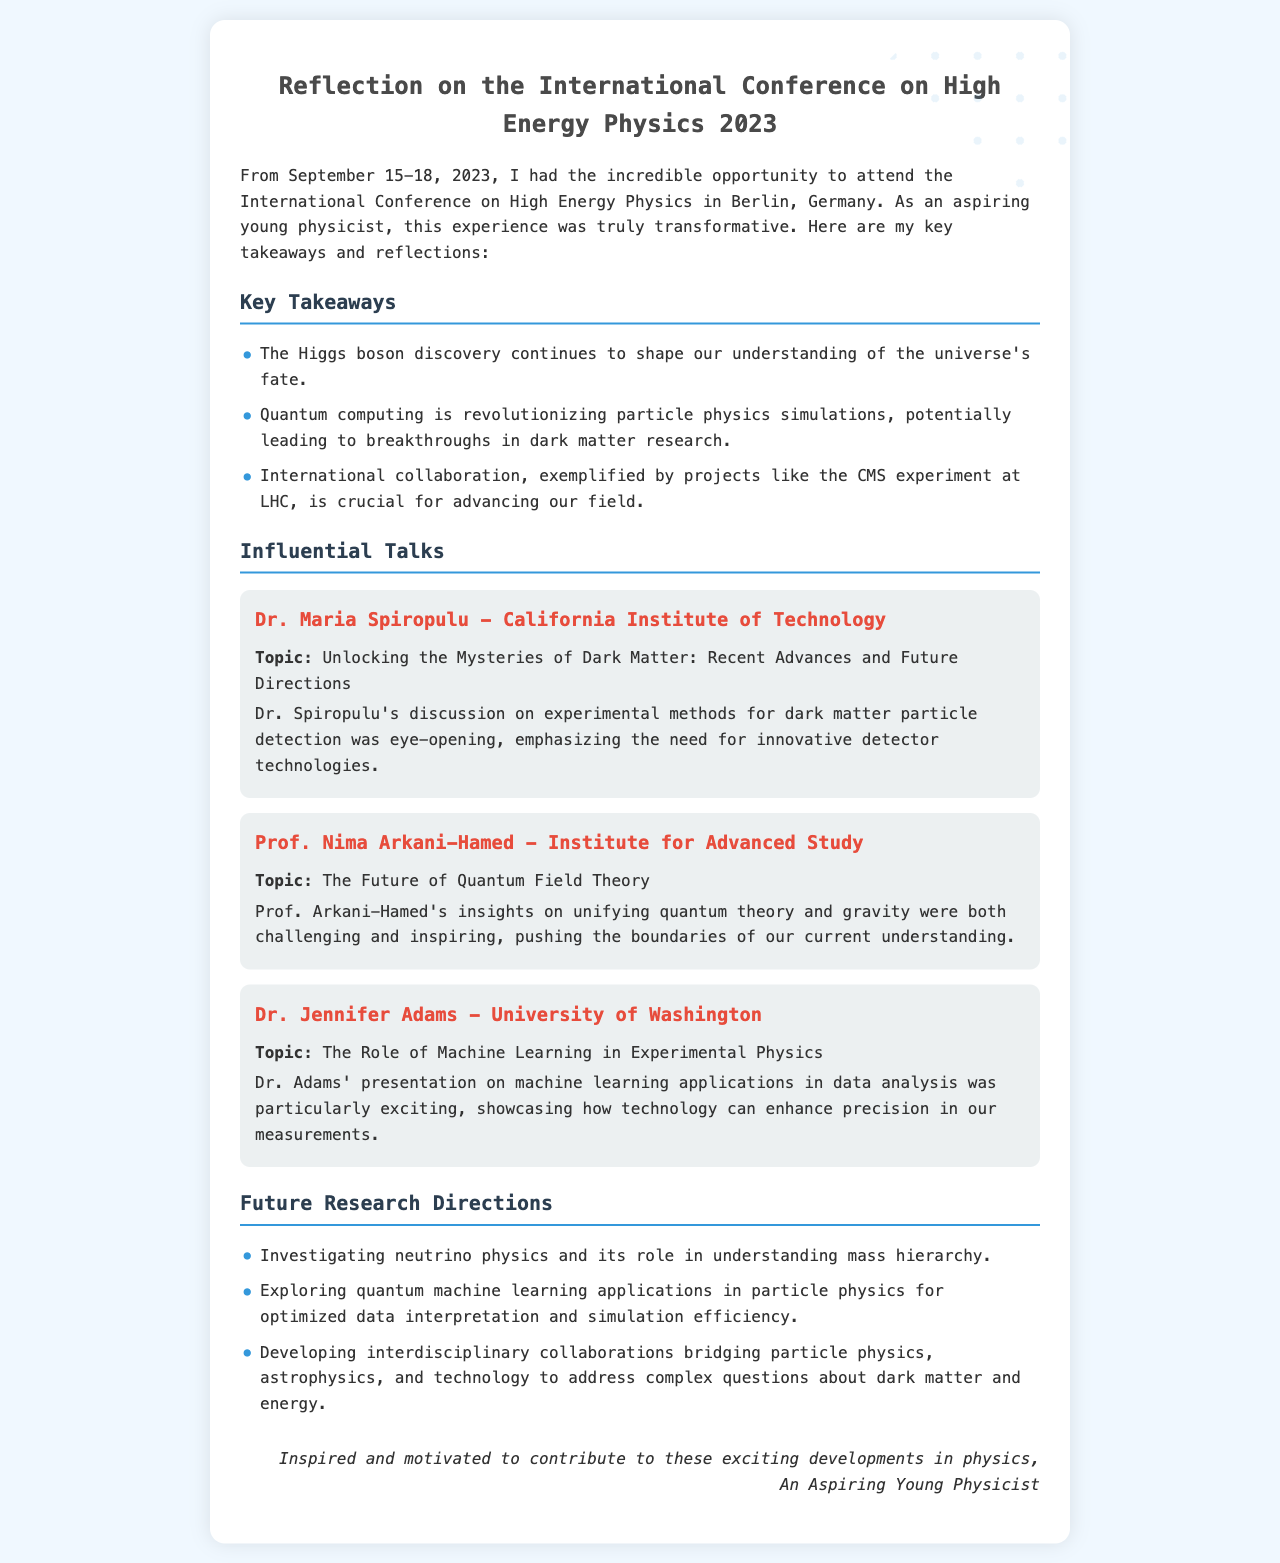What is the location of the conference? The document states that the conference was held in Berlin, Germany.
Answer: Berlin, Germany Who gave a talk on dark matter advancements? Dr. Maria Spiropulu was the speaker on this topic, as mentioned in the document.
Answer: Dr. Maria Spiropulu What is one key takeaway from the conference? The document lists several key takeaways, one of which is the continued impact of the Higgs boson discovery.
Answer: Higgs boson discovery What were the dates of the conference? The document specifies the conference occurred from September 15-18, 2023.
Answer: September 15-18, 2023 Which speaker discussed machine learning in experimental physics? Dr. Jennifer Adams is noted for this topic in the document.
Answer: Dr. Jennifer Adams What future research direction involves neutrinos? The document notes investigating neutrino physics regarding mass hierarchy.
Answer: Neutrino physics How many influential talks are mentioned in the document? Three influential talks are detailed in the letter.
Answer: Three What is a highlighted theme in Dr. Adams' talk? The presentation emphasized machine learning applications in data analysis.
Answer: Machine learning applications What message does the author convey at the end of the letter? The conclusion expresses the author's inspiration and motivation to contribute to physics developments.
Answer: Inspired and motivated 